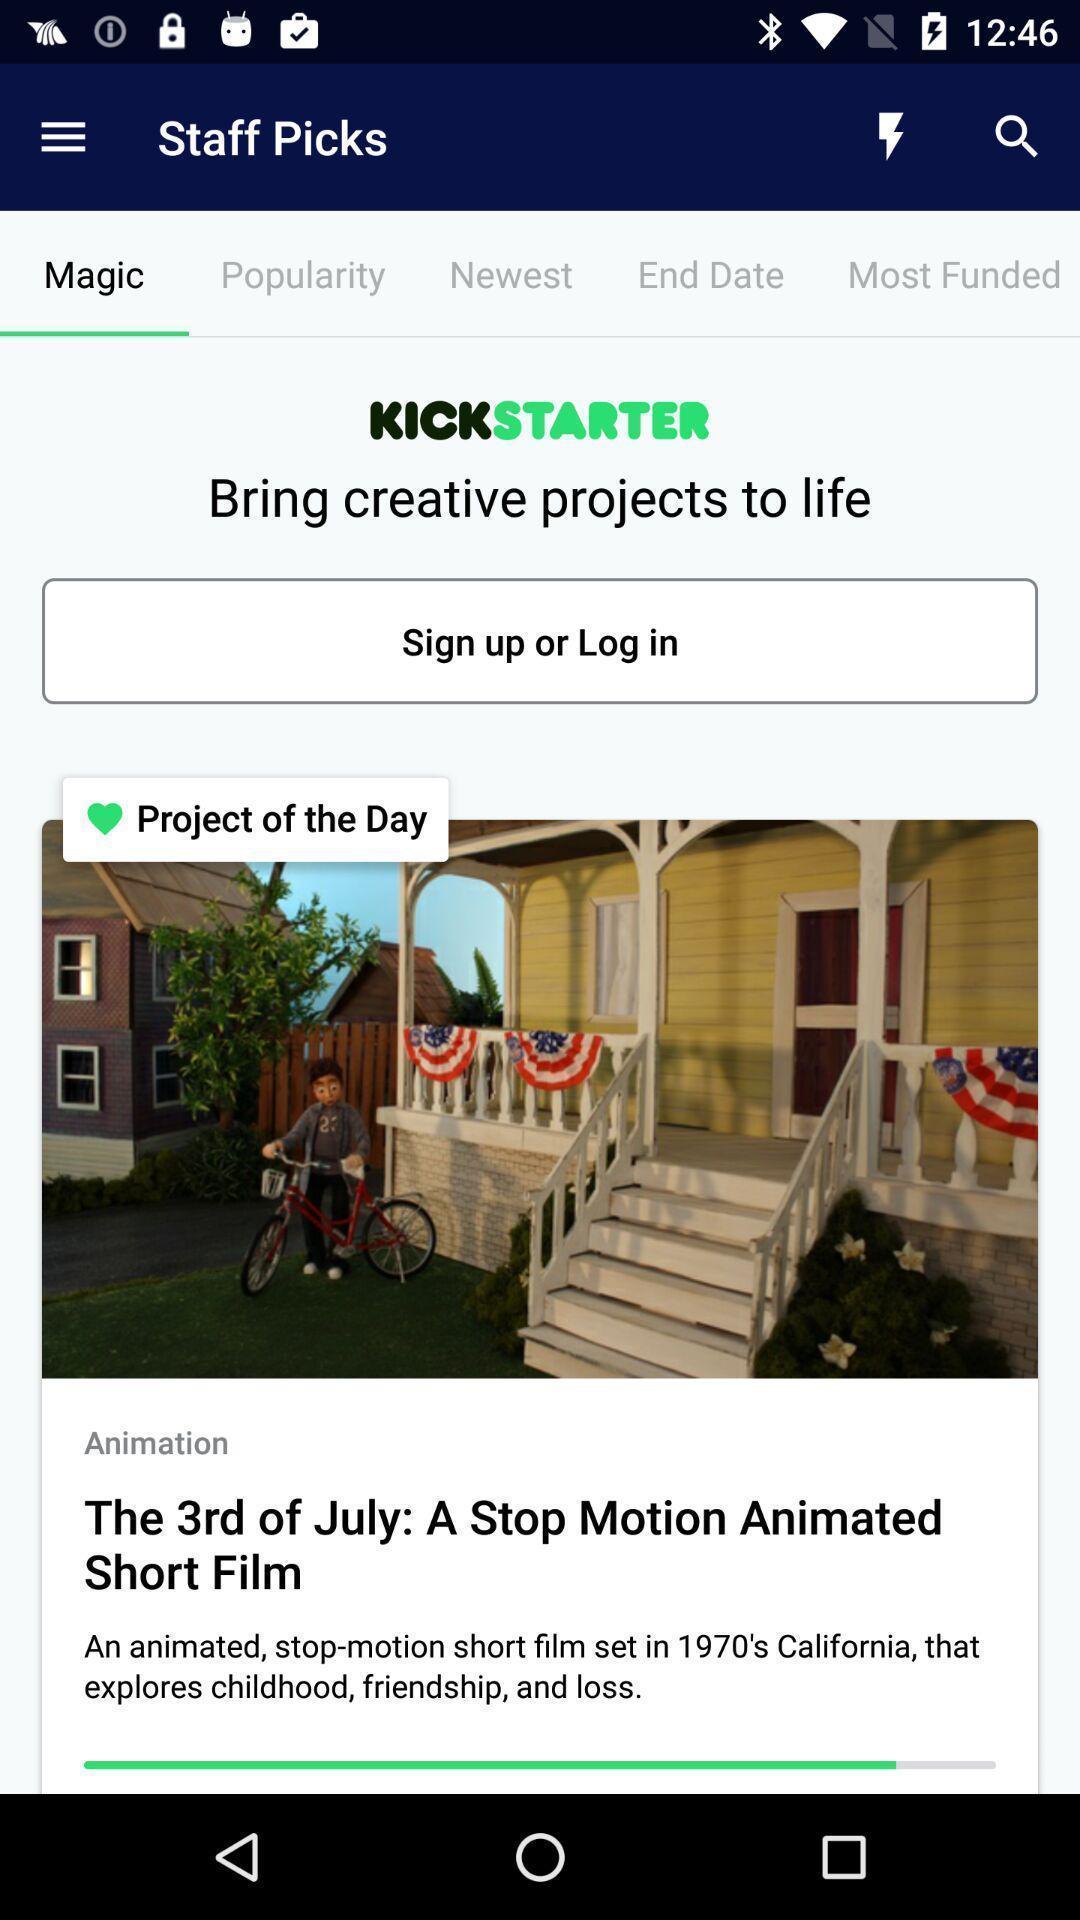Give me a narrative description of this picture. Screen showing log in page. 